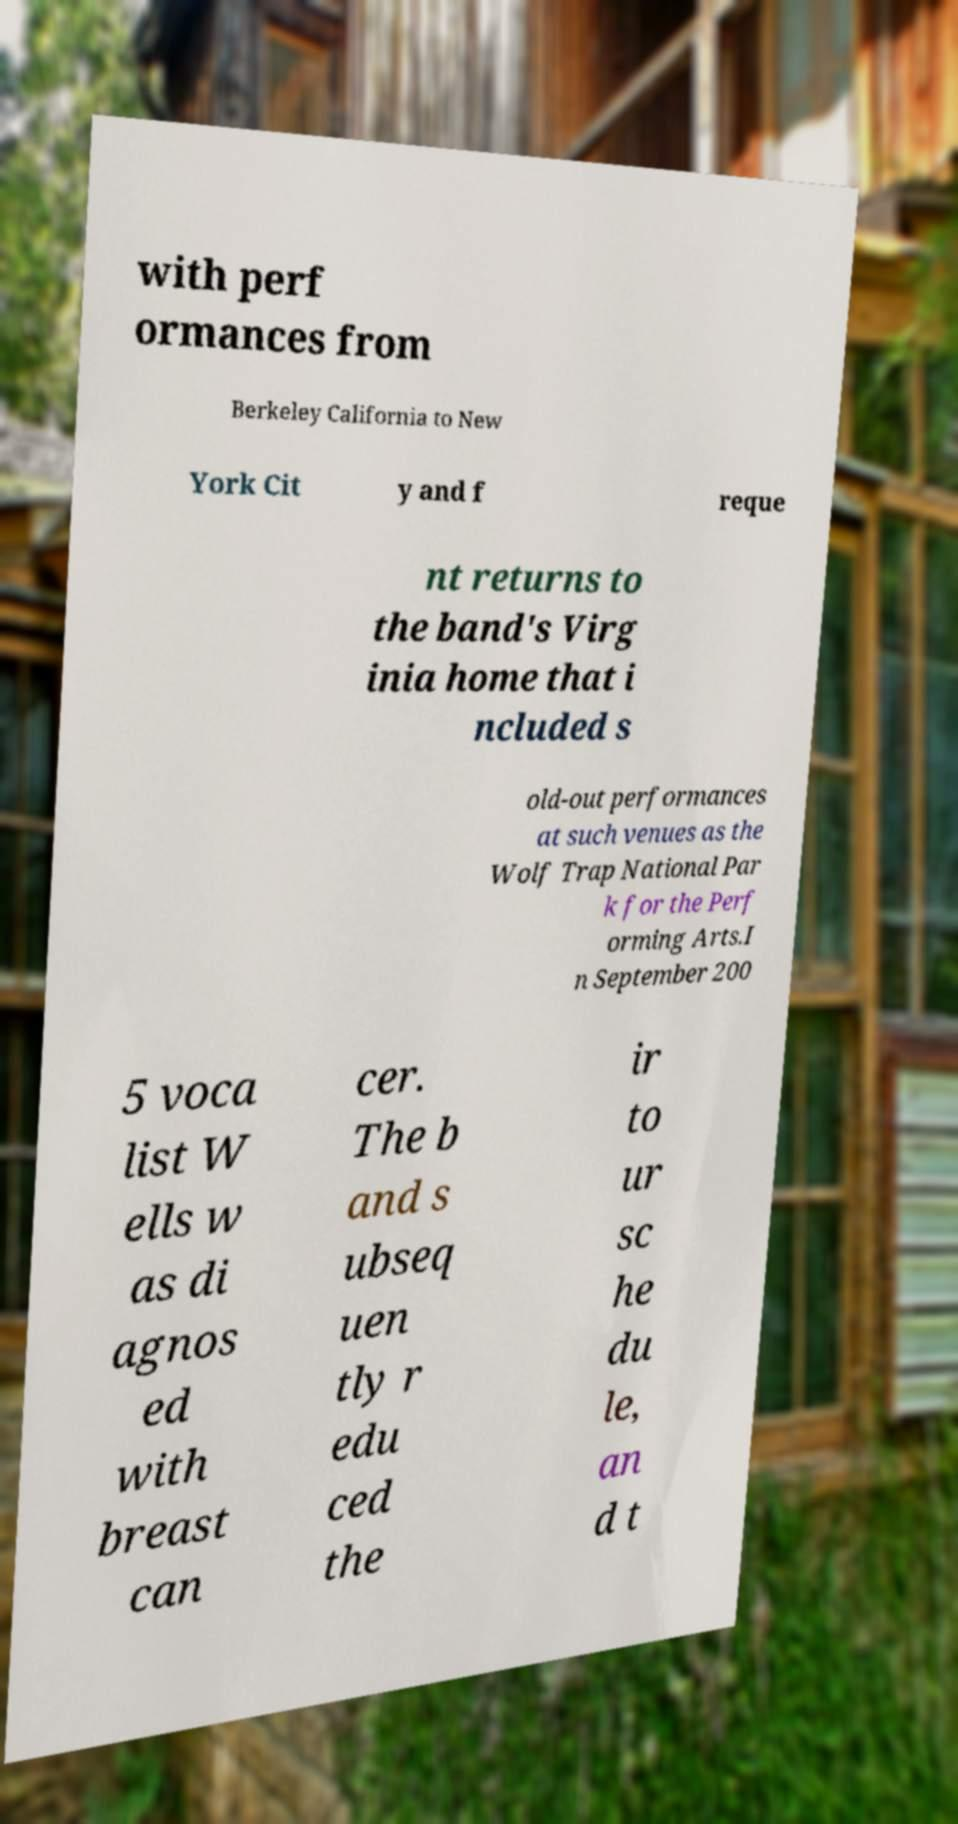Can you accurately transcribe the text from the provided image for me? with perf ormances from Berkeley California to New York Cit y and f reque nt returns to the band's Virg inia home that i ncluded s old-out performances at such venues as the Wolf Trap National Par k for the Perf orming Arts.I n September 200 5 voca list W ells w as di agnos ed with breast can cer. The b and s ubseq uen tly r edu ced the ir to ur sc he du le, an d t 